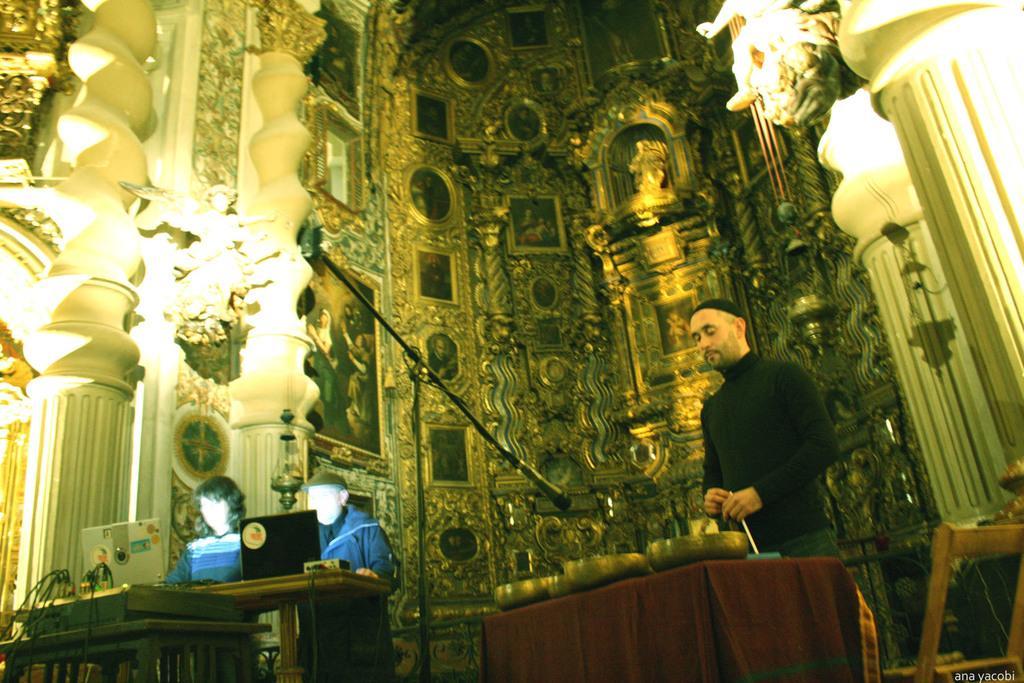Please provide a concise description of this image. The picture might be taken in a church. In the foreground of the picture there are tables, laptops, bowls, cables, stand, mic, some electronic gadgets and other objects. In the center of the picture there are pillars, wall, frames, sculptures. 